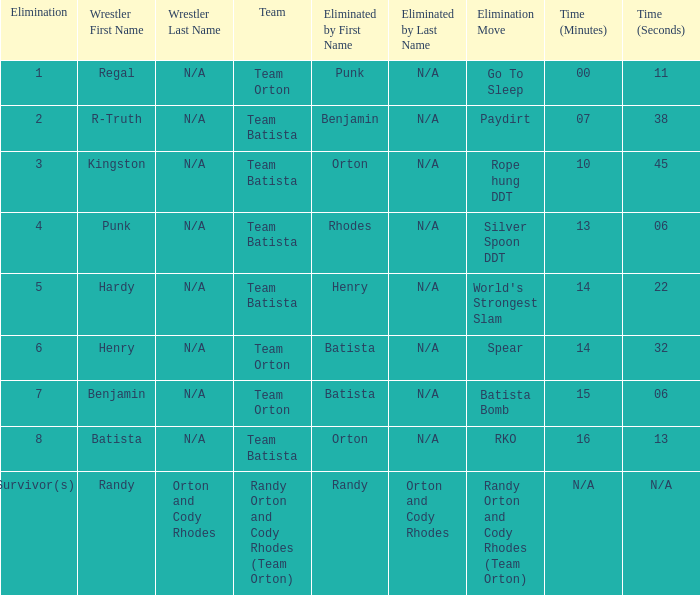Which Elimination Move is listed at Elimination 8 for Team Batista? RKO. 